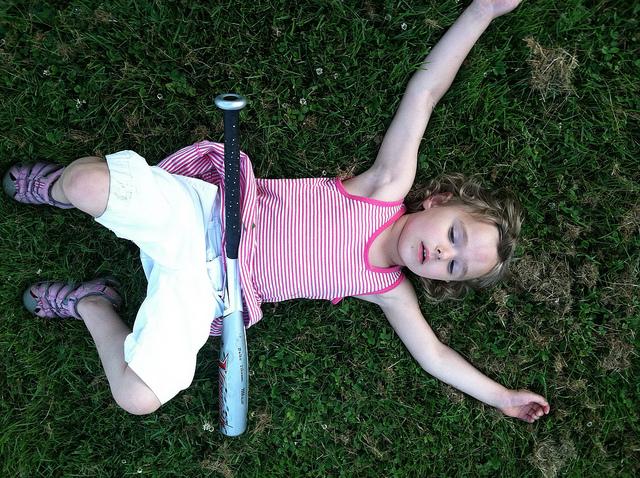What pattern is the shirt?
Give a very brief answer. Striped. What color is dominant?
Write a very short answer. Green. What is laying on top of the child?
Write a very short answer. Baseball bat. 